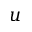Convert formula to latex. <formula><loc_0><loc_0><loc_500><loc_500>u</formula> 